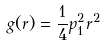Convert formula to latex. <formula><loc_0><loc_0><loc_500><loc_500>g ( r ) = \frac { 1 } { 4 } p _ { 1 } ^ { 2 } r ^ { 2 }</formula> 